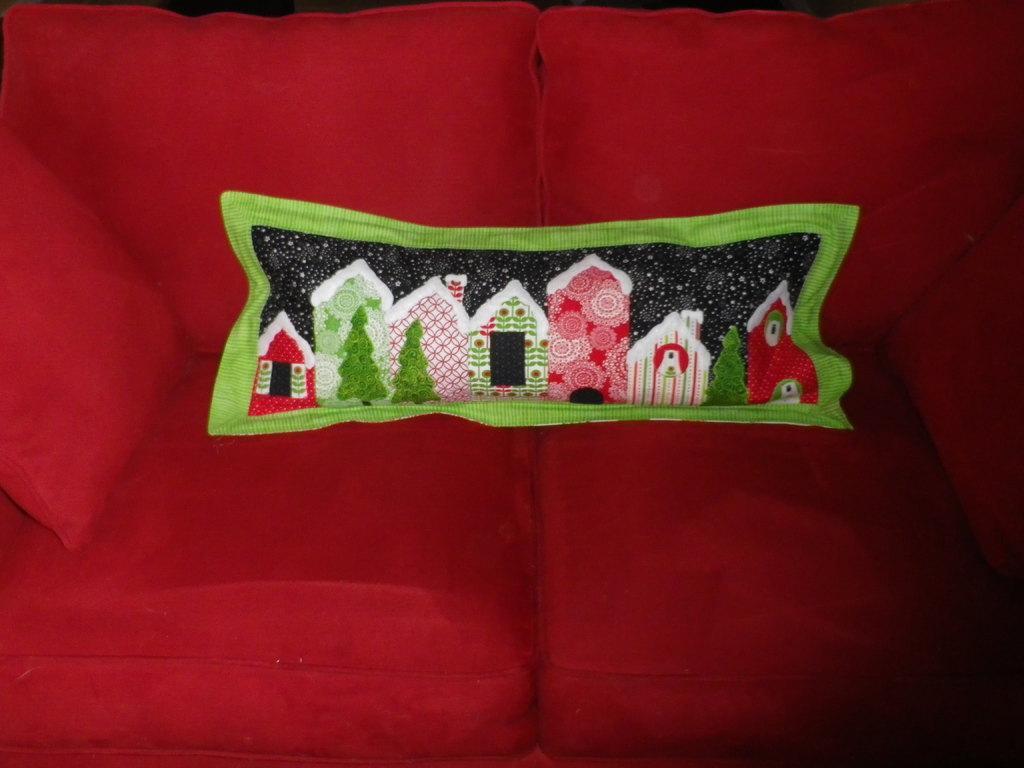Please provide a concise description of this image. In this image in the center there is a couch which is red in color, on the couch there are some pillows. 